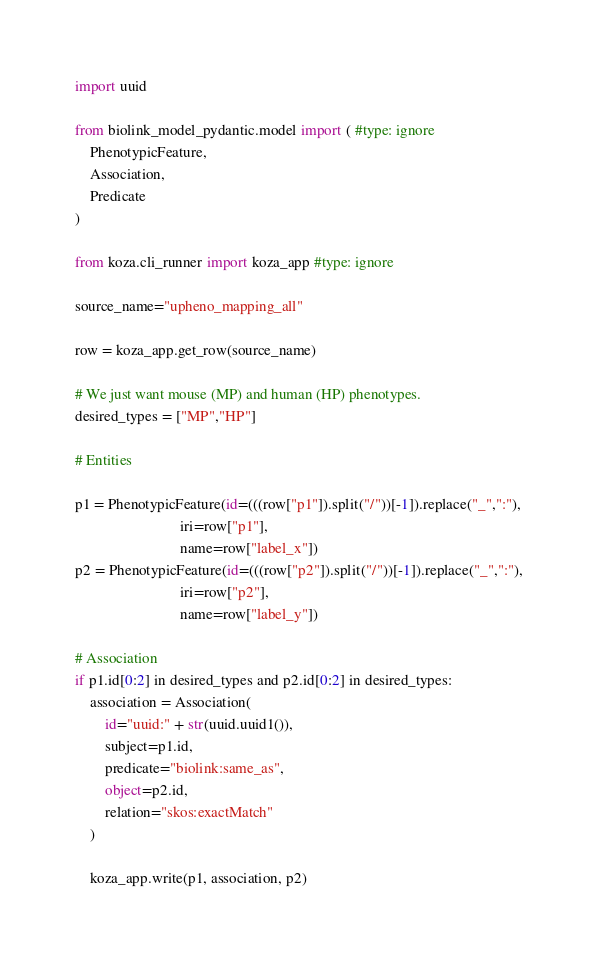Convert code to text. <code><loc_0><loc_0><loc_500><loc_500><_Python_>import uuid

from biolink_model_pydantic.model import ( #type: ignore
    PhenotypicFeature,
    Association,
    Predicate
)

from koza.cli_runner import koza_app #type: ignore

source_name="upheno_mapping_all"

row = koza_app.get_row(source_name)

# We just want mouse (MP) and human (HP) phenotypes.
desired_types = ["MP","HP"]

# Entities

p1 = PhenotypicFeature(id=(((row["p1"]).split("/"))[-1]).replace("_",":"),
                            iri=row["p1"],
                            name=row["label_x"])
p2 = PhenotypicFeature(id=(((row["p2"]).split("/"))[-1]).replace("_",":"),
                            iri=row["p2"],
                            name=row["label_y"])

# Association
if p1.id[0:2] in desired_types and p2.id[0:2] in desired_types:
    association = Association(
        id="uuid:" + str(uuid.uuid1()),
        subject=p1.id,
        predicate="biolink:same_as",
        object=p2.id,
        relation="skos:exactMatch"
    )

    koza_app.write(p1, association, p2)
</code> 